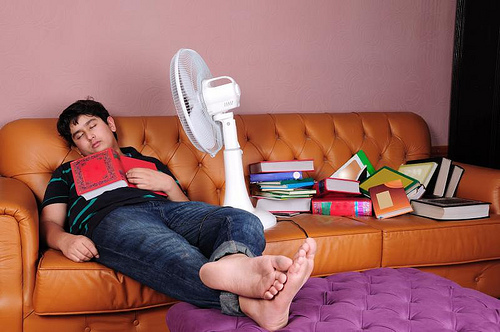<image>
Is there a fan next to the couch? No. The fan is not positioned next to the couch. They are located in different areas of the scene. Is the book on the man? Yes. Looking at the image, I can see the book is positioned on top of the man, with the man providing support. Is the fan on the couch? Yes. Looking at the image, I can see the fan is positioned on top of the couch, with the couch providing support. 